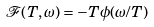<formula> <loc_0><loc_0><loc_500><loc_500>\mathcal { F } ( T , \omega ) = - T \phi ( \omega / T )</formula> 